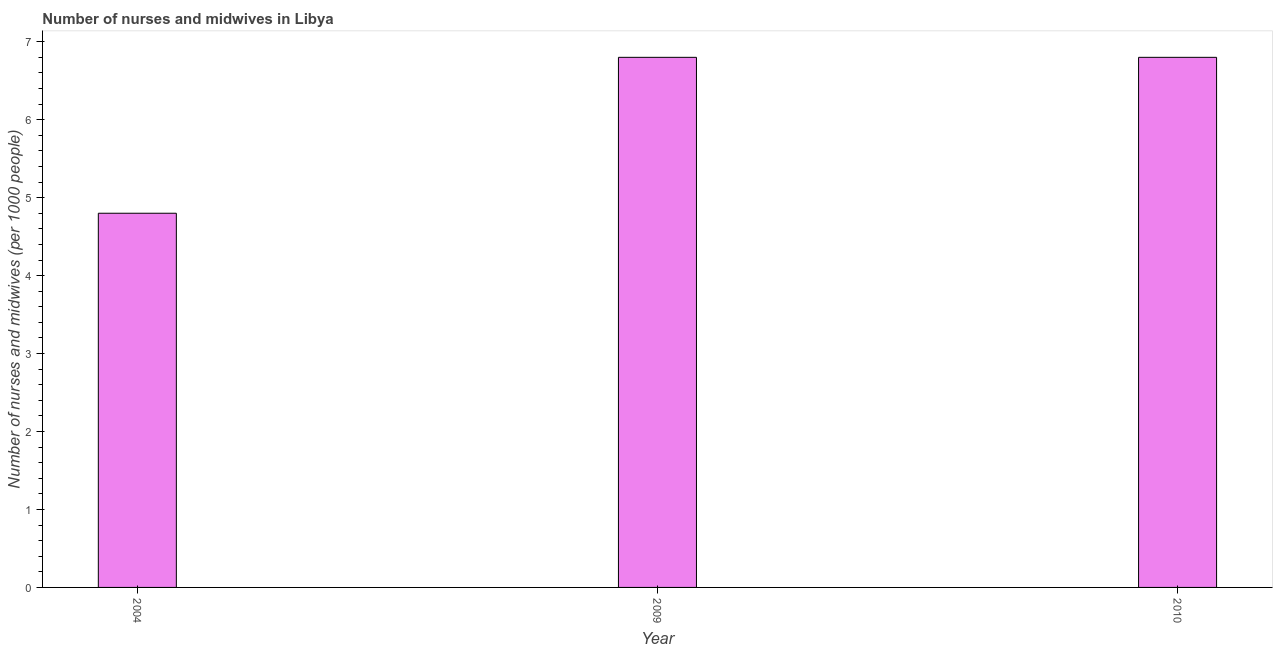Does the graph contain any zero values?
Offer a terse response. No. What is the title of the graph?
Ensure brevity in your answer.  Number of nurses and midwives in Libya. What is the label or title of the X-axis?
Your answer should be compact. Year. What is the label or title of the Y-axis?
Your response must be concise. Number of nurses and midwives (per 1000 people). What is the number of nurses and midwives in 2010?
Your answer should be compact. 6.8. In which year was the number of nurses and midwives minimum?
Provide a short and direct response. 2004. What is the average number of nurses and midwives per year?
Provide a succinct answer. 6.13. In how many years, is the number of nurses and midwives greater than 3.4 ?
Make the answer very short. 3. Is the number of nurses and midwives in 2009 less than that in 2010?
Your answer should be compact. No. Is the difference between the number of nurses and midwives in 2004 and 2009 greater than the difference between any two years?
Offer a very short reply. Yes. What is the difference between the highest and the second highest number of nurses and midwives?
Offer a very short reply. 0. Is the sum of the number of nurses and midwives in 2004 and 2009 greater than the maximum number of nurses and midwives across all years?
Provide a succinct answer. Yes. How many years are there in the graph?
Offer a terse response. 3. What is the difference between two consecutive major ticks on the Y-axis?
Make the answer very short. 1. What is the difference between the Number of nurses and midwives (per 1000 people) in 2009 and 2010?
Offer a terse response. 0. What is the ratio of the Number of nurses and midwives (per 1000 people) in 2004 to that in 2009?
Provide a short and direct response. 0.71. What is the ratio of the Number of nurses and midwives (per 1000 people) in 2004 to that in 2010?
Provide a succinct answer. 0.71. What is the ratio of the Number of nurses and midwives (per 1000 people) in 2009 to that in 2010?
Provide a succinct answer. 1. 